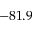Convert formula to latex. <formula><loc_0><loc_0><loc_500><loc_500>- 8 1 . 9</formula> 